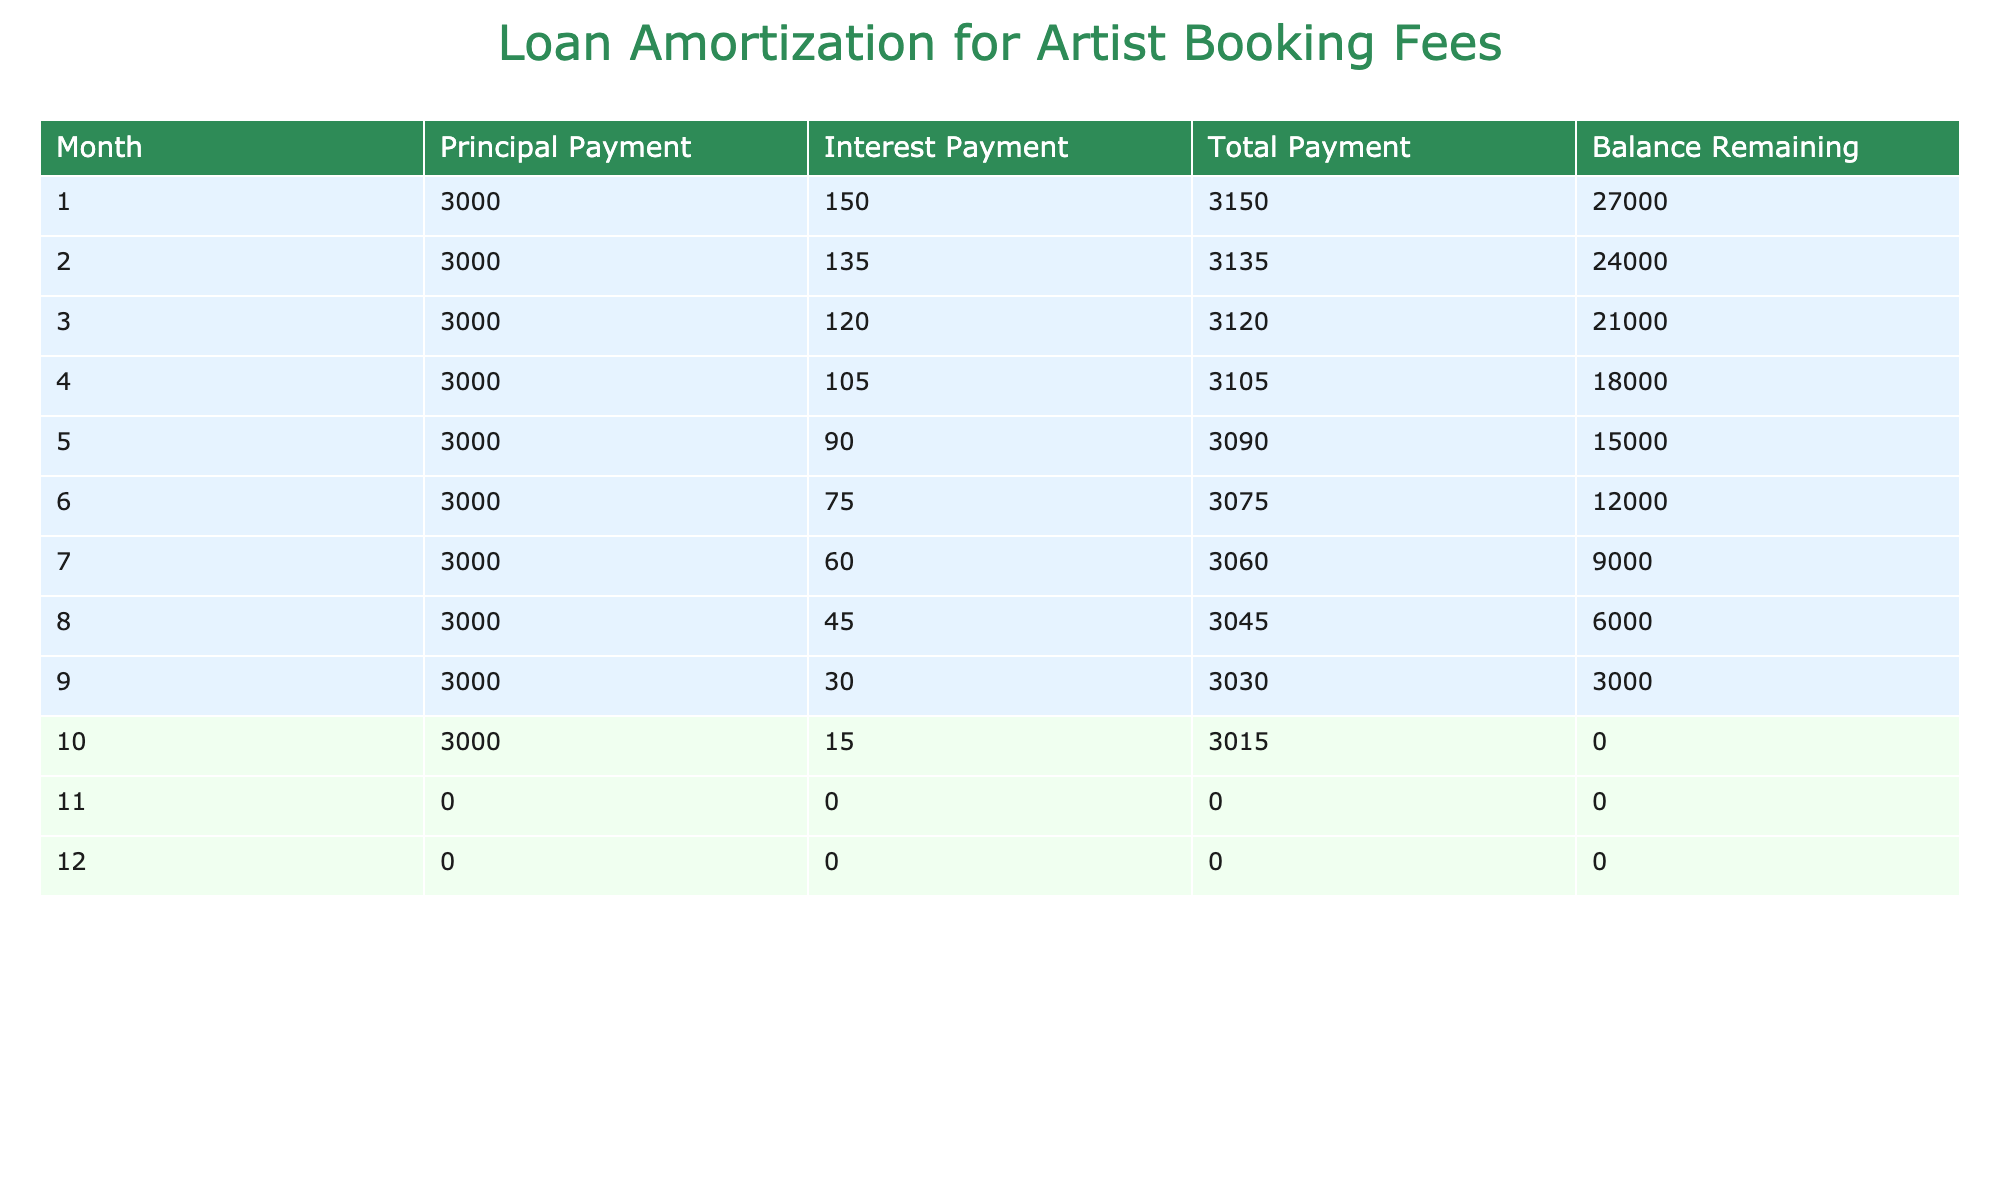What is the total payment made in the first month? The total payment for the first month is listed in the table under the "Total Payment" column for month 1, which shows a value of 3150.
Answer: 3150 What was the balance remaining after the third month? The balance remaining after the third month is found in the "Balance Remaining" column for month 3, which indicates a value of 21000.
Answer: 21000 How much total interest was paid over the 12 months? To find the total interest paid, we sum the values in the "Interest Payment" column for months 1 through 10. Adding 150 + 135 + 120 + 105 + 90 + 75 + 60 + 45 + 30 + 15 gives us 1050. The remaining months show no interest payments.
Answer: 1050 Did any month have a zero principal payment? Reviewing the table, both months 11 and 12 show a principal payment of 0, indicating there were no payments made in those months.
Answer: Yes What is the average total payment made over the first 10 months? To find the average total payment over the first 10 months, we first sum the total payments: 3150 + 3135 + 3120 + 3105 + 3090 + 3075 + 3060 + 3045 + 3030 + 3015 = 30900. Dividing this sum by the number of months (10) yields an average of 3090.
Answer: 3090 In which month was the principal payment equal to 3000? Upon reviewing the “Principal Payment” column, every month from 1 to 10 shows a principal payment of 3000. Therefore, all these months meet the criteria.
Answer: Months 1 to 10 What is the total remaining balance after month 6? The balance remaining after month 6 is directly listed in the table under "Balance Remaining" for month 6, which shows 12000.
Answer: 12000 How much less was paid in interest in the second month compared to the first month? From the "Interest Payment" column, the first month had an interest payment of 150, while the second month had an interest payment of 135. Subtracting these gives 150 - 135 = 15.
Answer: 15 How many months had a total payment less than 3100? Analyzing the “Total Payment” column for months 1 through 10 reveals that only months 5 to 10 had total payments below 3100. Specifically, months 5 (3090), 6 (3075), 7 (3060), 8 (3045), 9 (3030), and 10 (3015) qualify, amounting to 6 months.
Answer: 6 